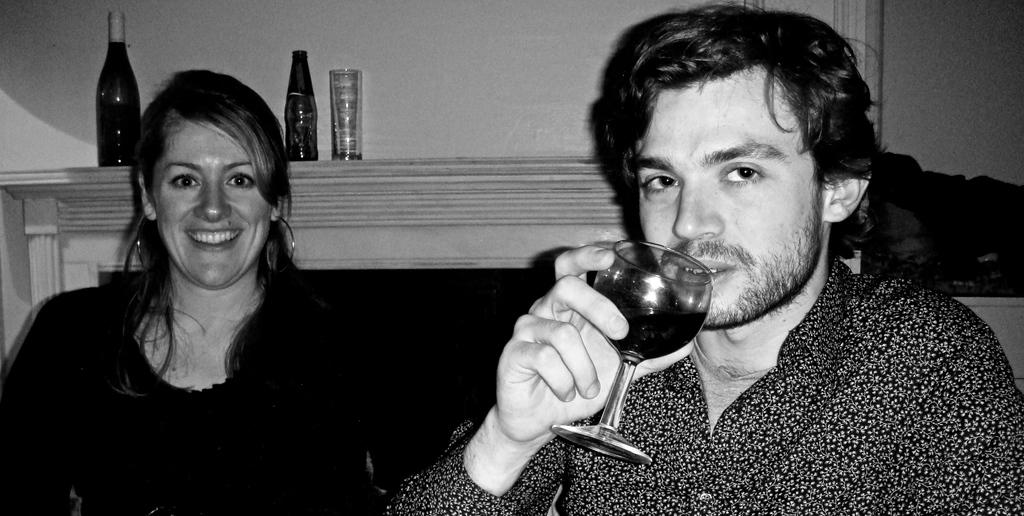How many people are in the image? There are two persons in the image. What objects can be seen in the background of the image? There is a bottle, a glass, and a fireplace in the background of the image. What type of operation is being performed on the cows in the image? There are no cows or any indication of an operation in the image. 